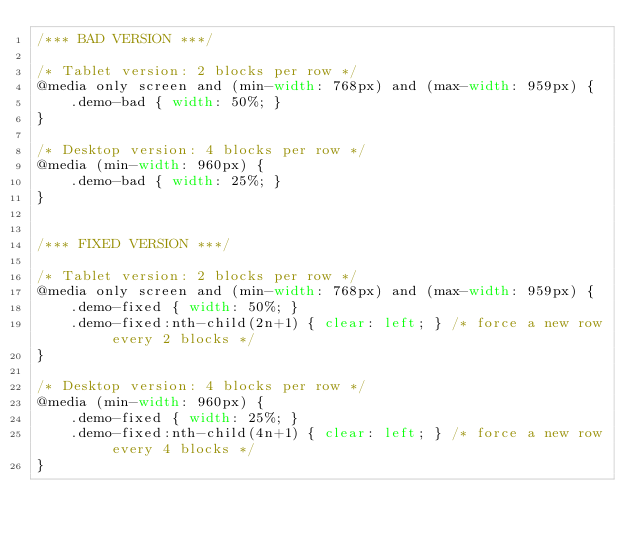<code> <loc_0><loc_0><loc_500><loc_500><_CSS_>/*** BAD VERSION ***/

/* Tablet version: 2 blocks per row */
@media only screen and (min-width: 768px) and (max-width: 959px) {
    .demo-bad { width: 50%; }
}

/* Desktop version: 4 blocks per row */
@media (min-width: 960px) {
    .demo-bad { width: 25%; }
}


/*** FIXED VERSION ***/

/* Tablet version: 2 blocks per row */
@media only screen and (min-width: 768px) and (max-width: 959px) {
    .demo-fixed { width: 50%; }
    .demo-fixed:nth-child(2n+1) { clear: left; } /* force a new row every 2 blocks */
}

/* Desktop version: 4 blocks per row */
@media (min-width: 960px) {
    .demo-fixed { width: 25%; }
    .demo-fixed:nth-child(4n+1) { clear: left; } /* force a new row every 4 blocks */
}
</code> 